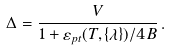Convert formula to latex. <formula><loc_0><loc_0><loc_500><loc_500>\Delta = \frac { V } { 1 + \varepsilon _ { p t } ( T , \{ \lambda \} ) / 4 B } \, .</formula> 